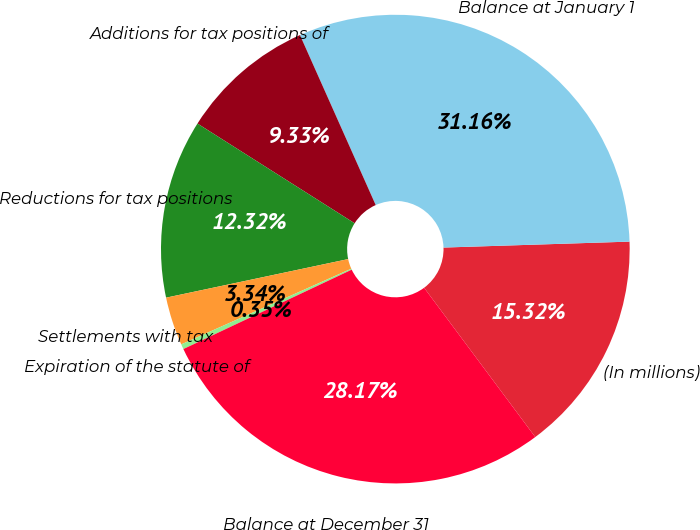Convert chart to OTSL. <chart><loc_0><loc_0><loc_500><loc_500><pie_chart><fcel>(In millions)<fcel>Balance at January 1<fcel>Additions for tax positions of<fcel>Reductions for tax positions<fcel>Settlements with tax<fcel>Expiration of the statute of<fcel>Balance at December 31<nl><fcel>15.32%<fcel>31.16%<fcel>9.33%<fcel>12.32%<fcel>3.34%<fcel>0.35%<fcel>28.17%<nl></chart> 